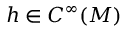Convert formula to latex. <formula><loc_0><loc_0><loc_500><loc_500>h \in C ^ { \infty } ( M )</formula> 